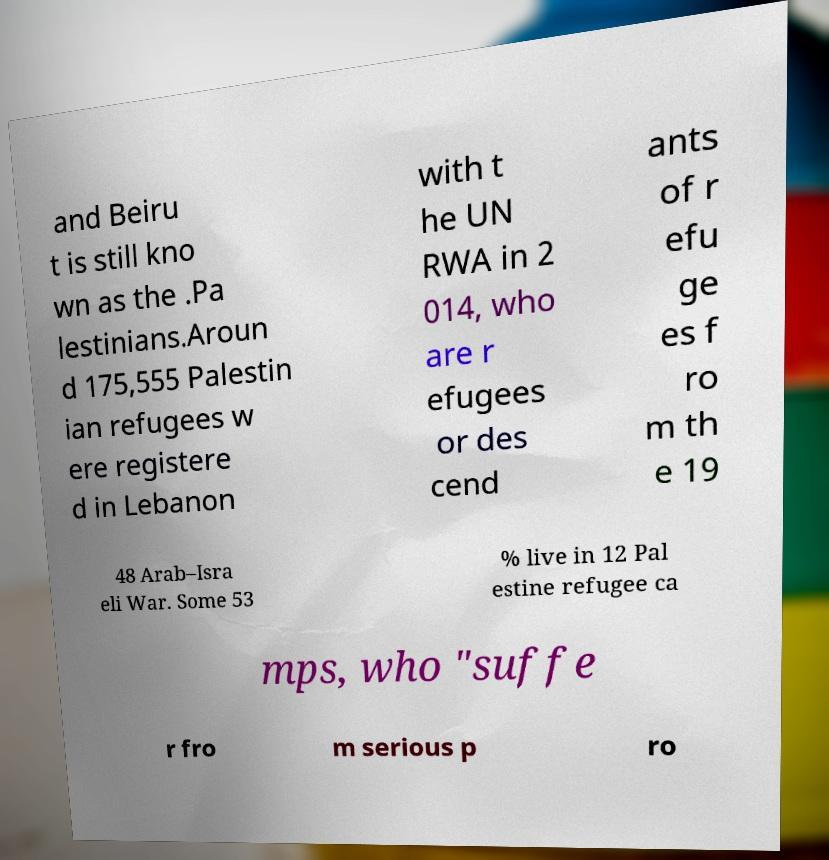Please read and relay the text visible in this image. What does it say? and Beiru t is still kno wn as the .Pa lestinians.Aroun d 175,555 Palestin ian refugees w ere registere d in Lebanon with t he UN RWA in 2 014, who are r efugees or des cend ants of r efu ge es f ro m th e 19 48 Arab–Isra eli War. Some 53 % live in 12 Pal estine refugee ca mps, who "suffe r fro m serious p ro 